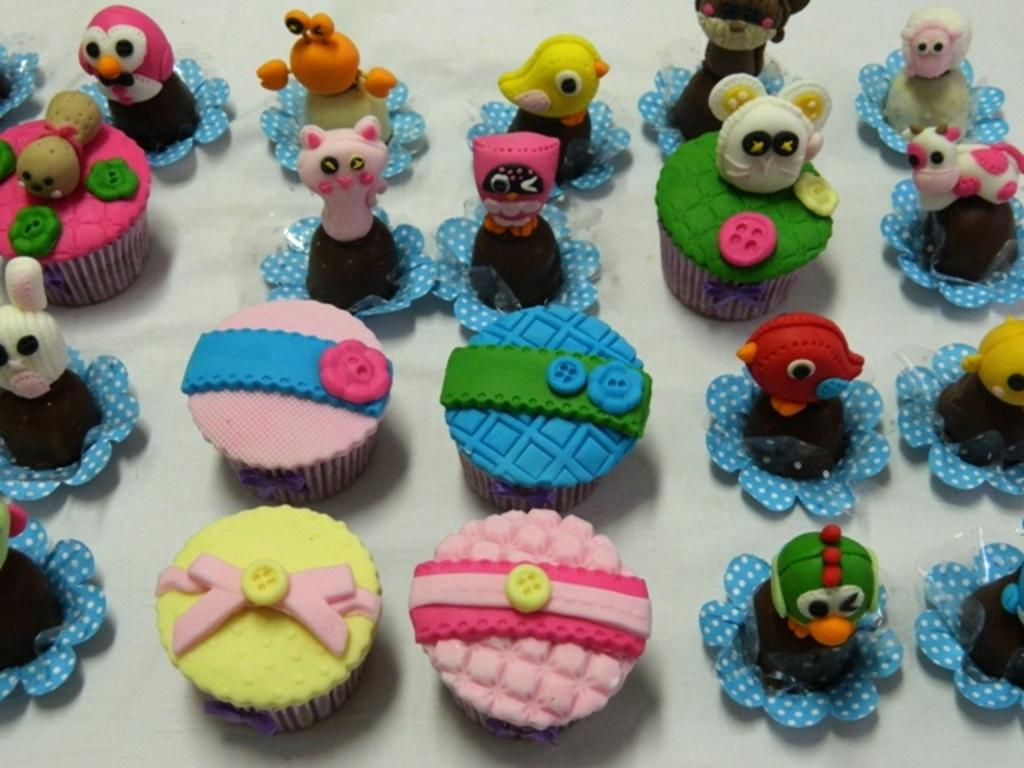What type of food is visible in the image? There are cupcakes in the image. What other items can be seen in the image besides the cupcakes? There are toys in the image. What is the color of the surface on which the cupcakes and toys are placed? The cupcakes and toys are on a white surface. How many colors can be observed in the cupcakes and toys? The cupcakes and toys have multiple colors. What month is it in the image? The image does not provide any information about the month or time of year. 